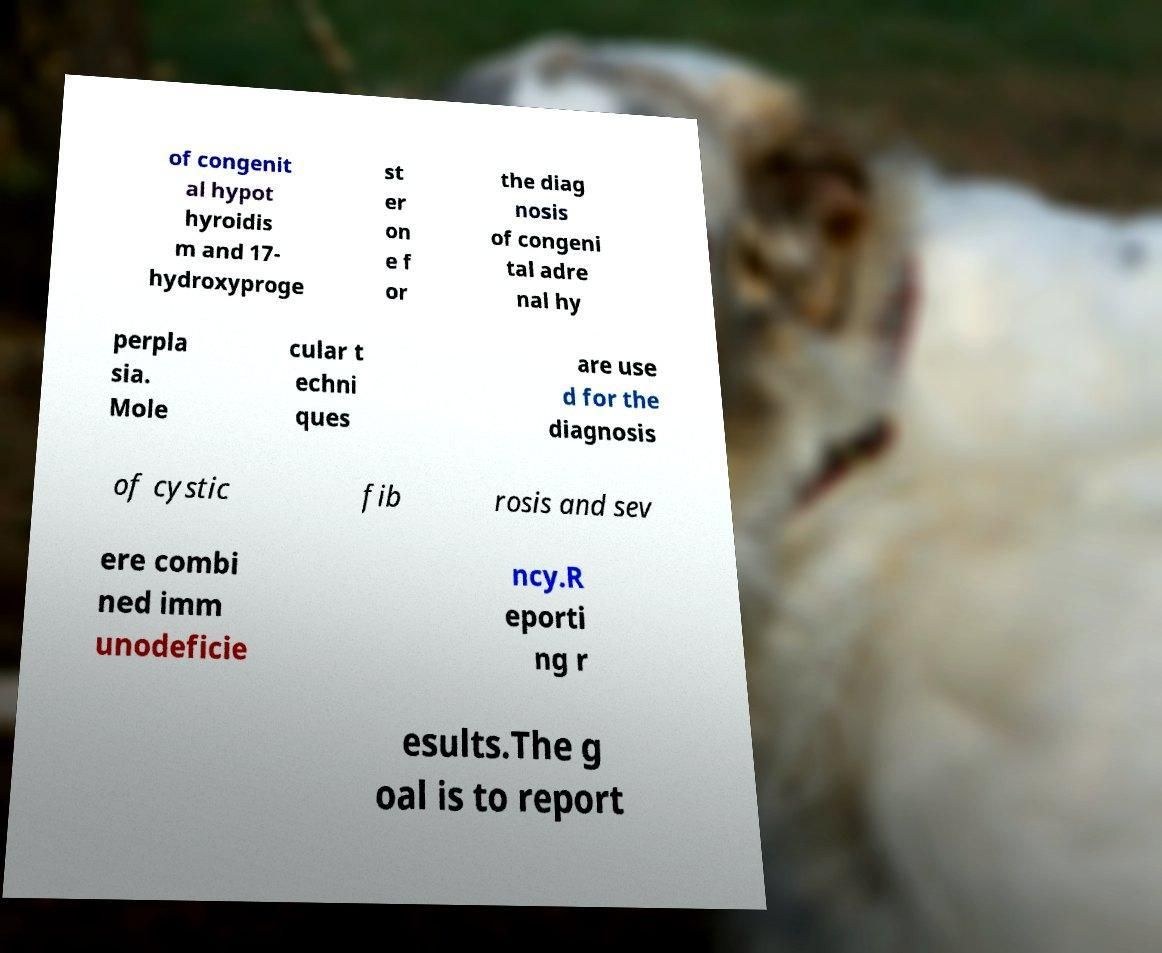Please identify and transcribe the text found in this image. of congenit al hypot hyroidis m and 17- hydroxyproge st er on e f or the diag nosis of congeni tal adre nal hy perpla sia. Mole cular t echni ques are use d for the diagnosis of cystic fib rosis and sev ere combi ned imm unodeficie ncy.R eporti ng r esults.The g oal is to report 